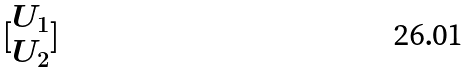<formula> <loc_0><loc_0><loc_500><loc_500>[ \begin{matrix} U _ { 1 } \\ U _ { 2 } \end{matrix} ]</formula> 